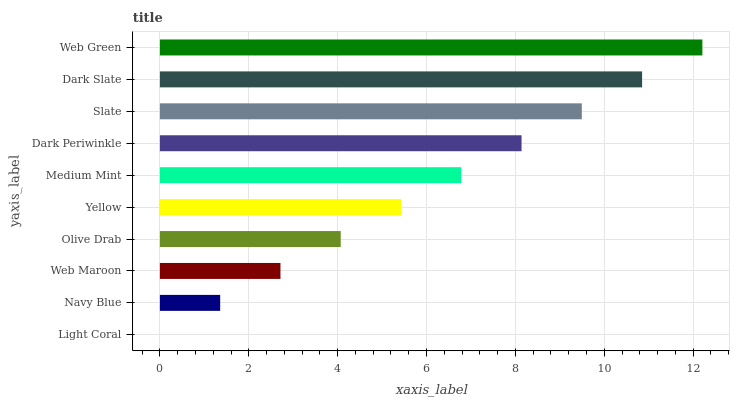Is Light Coral the minimum?
Answer yes or no. Yes. Is Web Green the maximum?
Answer yes or no. Yes. Is Navy Blue the minimum?
Answer yes or no. No. Is Navy Blue the maximum?
Answer yes or no. No. Is Navy Blue greater than Light Coral?
Answer yes or no. Yes. Is Light Coral less than Navy Blue?
Answer yes or no. Yes. Is Light Coral greater than Navy Blue?
Answer yes or no. No. Is Navy Blue less than Light Coral?
Answer yes or no. No. Is Medium Mint the high median?
Answer yes or no. Yes. Is Yellow the low median?
Answer yes or no. Yes. Is Slate the high median?
Answer yes or no. No. Is Navy Blue the low median?
Answer yes or no. No. 